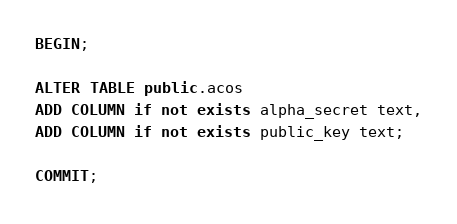Convert code to text. <code><loc_0><loc_0><loc_500><loc_500><_SQL_>BEGIN;

ALTER TABLE public.acos
ADD COLUMN if not exists alpha_secret text,
ADD COLUMN if not exists public_key text;

COMMIT;</code> 